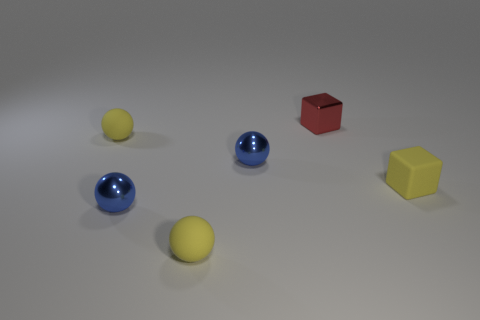Add 1 small cubes. How many objects exist? 7 Subtract all cyan balls. Subtract all purple blocks. How many balls are left? 4 Subtract all balls. How many objects are left? 2 Subtract 0 brown cubes. How many objects are left? 6 Subtract all tiny yellow matte blocks. Subtract all small shiny cylinders. How many objects are left? 5 Add 6 balls. How many balls are left? 10 Add 3 blocks. How many blocks exist? 5 